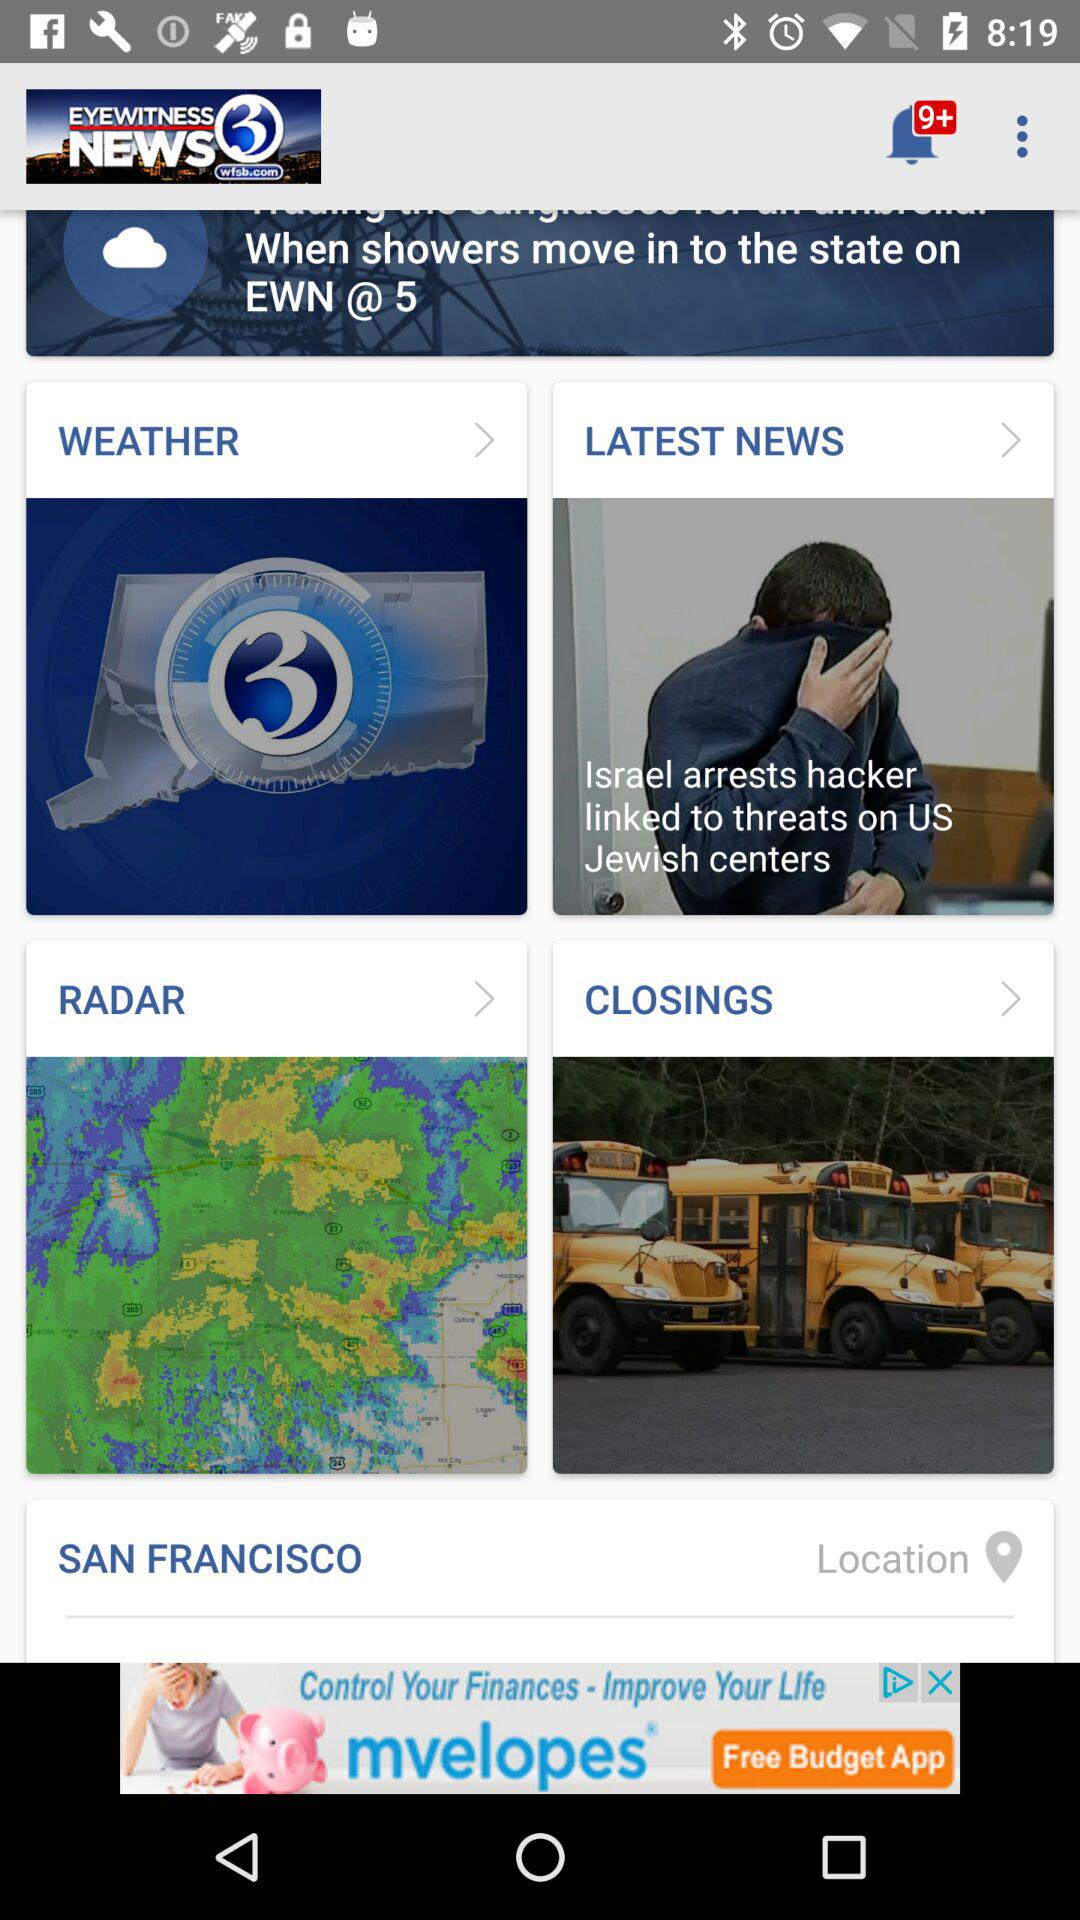What is the application name? The application name is "EYEWITNESS NEWS 3". 